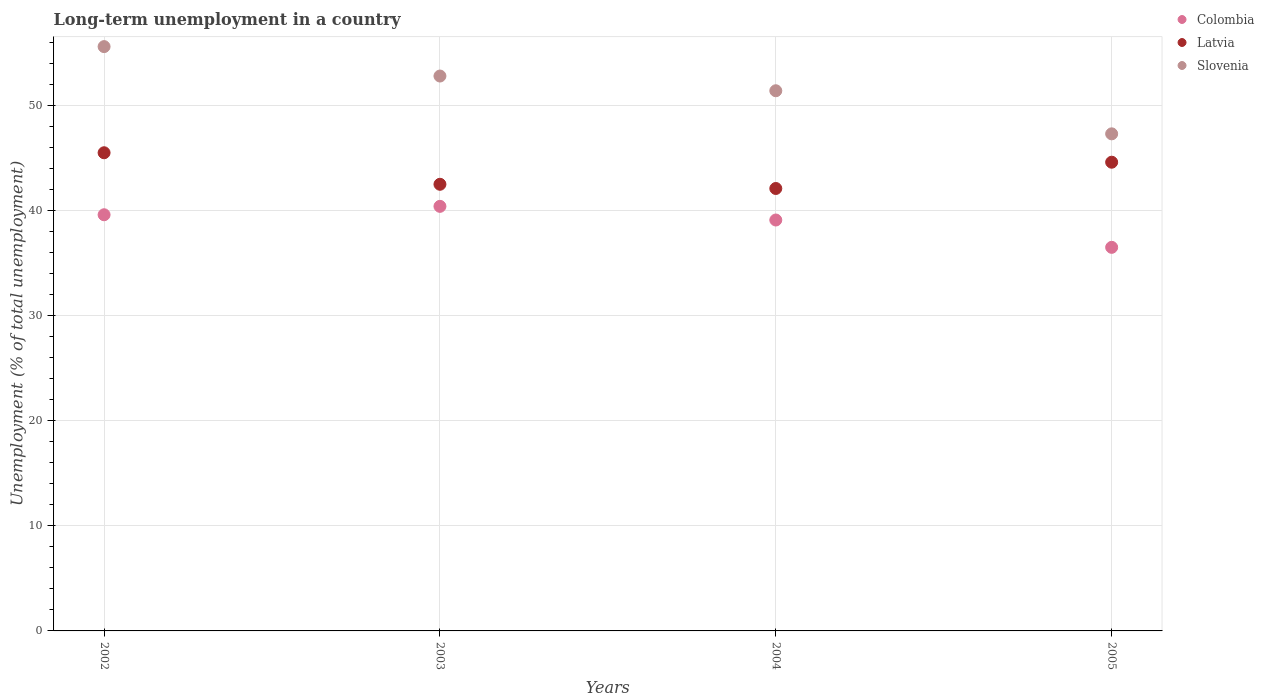What is the percentage of long-term unemployed population in Slovenia in 2005?
Give a very brief answer. 47.3. Across all years, what is the maximum percentage of long-term unemployed population in Latvia?
Your response must be concise. 45.5. Across all years, what is the minimum percentage of long-term unemployed population in Colombia?
Keep it short and to the point. 36.5. What is the total percentage of long-term unemployed population in Colombia in the graph?
Your response must be concise. 155.6. What is the difference between the percentage of long-term unemployed population in Colombia in 2004 and that in 2005?
Give a very brief answer. 2.6. What is the difference between the percentage of long-term unemployed population in Slovenia in 2004 and the percentage of long-term unemployed population in Colombia in 2002?
Your answer should be compact. 11.8. What is the average percentage of long-term unemployed population in Latvia per year?
Your answer should be compact. 43.67. In the year 2004, what is the difference between the percentage of long-term unemployed population in Colombia and percentage of long-term unemployed population in Slovenia?
Offer a terse response. -12.3. What is the ratio of the percentage of long-term unemployed population in Latvia in 2002 to that in 2005?
Offer a terse response. 1.02. Is the difference between the percentage of long-term unemployed population in Colombia in 2002 and 2004 greater than the difference between the percentage of long-term unemployed population in Slovenia in 2002 and 2004?
Keep it short and to the point. No. What is the difference between the highest and the second highest percentage of long-term unemployed population in Latvia?
Your answer should be very brief. 0.9. What is the difference between the highest and the lowest percentage of long-term unemployed population in Colombia?
Provide a succinct answer. 3.9. In how many years, is the percentage of long-term unemployed population in Slovenia greater than the average percentage of long-term unemployed population in Slovenia taken over all years?
Make the answer very short. 2. Is the sum of the percentage of long-term unemployed population in Slovenia in 2002 and 2003 greater than the maximum percentage of long-term unemployed population in Colombia across all years?
Give a very brief answer. Yes. Is the percentage of long-term unemployed population in Slovenia strictly greater than the percentage of long-term unemployed population in Latvia over the years?
Provide a short and direct response. Yes. Is the percentage of long-term unemployed population in Latvia strictly less than the percentage of long-term unemployed population in Colombia over the years?
Give a very brief answer. No. How many dotlines are there?
Give a very brief answer. 3. How many years are there in the graph?
Your answer should be compact. 4. How many legend labels are there?
Make the answer very short. 3. What is the title of the graph?
Your response must be concise. Long-term unemployment in a country. What is the label or title of the Y-axis?
Ensure brevity in your answer.  Unemployment (% of total unemployment). What is the Unemployment (% of total unemployment) of Colombia in 2002?
Your answer should be very brief. 39.6. What is the Unemployment (% of total unemployment) of Latvia in 2002?
Ensure brevity in your answer.  45.5. What is the Unemployment (% of total unemployment) in Slovenia in 2002?
Make the answer very short. 55.6. What is the Unemployment (% of total unemployment) of Colombia in 2003?
Your answer should be compact. 40.4. What is the Unemployment (% of total unemployment) of Latvia in 2003?
Provide a short and direct response. 42.5. What is the Unemployment (% of total unemployment) in Slovenia in 2003?
Provide a short and direct response. 52.8. What is the Unemployment (% of total unemployment) of Colombia in 2004?
Offer a very short reply. 39.1. What is the Unemployment (% of total unemployment) in Latvia in 2004?
Provide a short and direct response. 42.1. What is the Unemployment (% of total unemployment) in Slovenia in 2004?
Your answer should be very brief. 51.4. What is the Unemployment (% of total unemployment) in Colombia in 2005?
Provide a succinct answer. 36.5. What is the Unemployment (% of total unemployment) in Latvia in 2005?
Your response must be concise. 44.6. What is the Unemployment (% of total unemployment) in Slovenia in 2005?
Your answer should be very brief. 47.3. Across all years, what is the maximum Unemployment (% of total unemployment) of Colombia?
Your response must be concise. 40.4. Across all years, what is the maximum Unemployment (% of total unemployment) of Latvia?
Provide a succinct answer. 45.5. Across all years, what is the maximum Unemployment (% of total unemployment) in Slovenia?
Provide a succinct answer. 55.6. Across all years, what is the minimum Unemployment (% of total unemployment) of Colombia?
Your response must be concise. 36.5. Across all years, what is the minimum Unemployment (% of total unemployment) in Latvia?
Provide a succinct answer. 42.1. Across all years, what is the minimum Unemployment (% of total unemployment) in Slovenia?
Provide a succinct answer. 47.3. What is the total Unemployment (% of total unemployment) in Colombia in the graph?
Your answer should be very brief. 155.6. What is the total Unemployment (% of total unemployment) of Latvia in the graph?
Keep it short and to the point. 174.7. What is the total Unemployment (% of total unemployment) of Slovenia in the graph?
Your answer should be compact. 207.1. What is the difference between the Unemployment (% of total unemployment) in Colombia in 2002 and that in 2005?
Provide a succinct answer. 3.1. What is the difference between the Unemployment (% of total unemployment) in Slovenia in 2003 and that in 2004?
Your answer should be very brief. 1.4. What is the difference between the Unemployment (% of total unemployment) in Colombia in 2003 and that in 2005?
Your response must be concise. 3.9. What is the difference between the Unemployment (% of total unemployment) of Latvia in 2003 and that in 2005?
Your answer should be compact. -2.1. What is the difference between the Unemployment (% of total unemployment) in Slovenia in 2003 and that in 2005?
Your answer should be very brief. 5.5. What is the difference between the Unemployment (% of total unemployment) in Colombia in 2004 and that in 2005?
Keep it short and to the point. 2.6. What is the difference between the Unemployment (% of total unemployment) in Slovenia in 2004 and that in 2005?
Your response must be concise. 4.1. What is the difference between the Unemployment (% of total unemployment) of Colombia in 2002 and the Unemployment (% of total unemployment) of Latvia in 2003?
Keep it short and to the point. -2.9. What is the difference between the Unemployment (% of total unemployment) of Colombia in 2002 and the Unemployment (% of total unemployment) of Slovenia in 2003?
Your answer should be compact. -13.2. What is the difference between the Unemployment (% of total unemployment) of Colombia in 2002 and the Unemployment (% of total unemployment) of Slovenia in 2004?
Your answer should be compact. -11.8. What is the difference between the Unemployment (% of total unemployment) in Colombia in 2002 and the Unemployment (% of total unemployment) in Latvia in 2005?
Make the answer very short. -5. What is the difference between the Unemployment (% of total unemployment) of Colombia in 2002 and the Unemployment (% of total unemployment) of Slovenia in 2005?
Offer a very short reply. -7.7. What is the difference between the Unemployment (% of total unemployment) of Latvia in 2003 and the Unemployment (% of total unemployment) of Slovenia in 2004?
Provide a succinct answer. -8.9. What is the difference between the Unemployment (% of total unemployment) in Colombia in 2003 and the Unemployment (% of total unemployment) in Latvia in 2005?
Your answer should be very brief. -4.2. What is the difference between the Unemployment (% of total unemployment) in Colombia in 2003 and the Unemployment (% of total unemployment) in Slovenia in 2005?
Offer a very short reply. -6.9. What is the difference between the Unemployment (% of total unemployment) of Latvia in 2003 and the Unemployment (% of total unemployment) of Slovenia in 2005?
Offer a terse response. -4.8. What is the difference between the Unemployment (% of total unemployment) of Colombia in 2004 and the Unemployment (% of total unemployment) of Latvia in 2005?
Provide a short and direct response. -5.5. What is the difference between the Unemployment (% of total unemployment) of Colombia in 2004 and the Unemployment (% of total unemployment) of Slovenia in 2005?
Your response must be concise. -8.2. What is the difference between the Unemployment (% of total unemployment) in Latvia in 2004 and the Unemployment (% of total unemployment) in Slovenia in 2005?
Provide a succinct answer. -5.2. What is the average Unemployment (% of total unemployment) of Colombia per year?
Provide a succinct answer. 38.9. What is the average Unemployment (% of total unemployment) in Latvia per year?
Provide a short and direct response. 43.67. What is the average Unemployment (% of total unemployment) of Slovenia per year?
Make the answer very short. 51.77. In the year 2002, what is the difference between the Unemployment (% of total unemployment) in Latvia and Unemployment (% of total unemployment) in Slovenia?
Ensure brevity in your answer.  -10.1. In the year 2003, what is the difference between the Unemployment (% of total unemployment) of Colombia and Unemployment (% of total unemployment) of Latvia?
Provide a succinct answer. -2.1. In the year 2003, what is the difference between the Unemployment (% of total unemployment) in Colombia and Unemployment (% of total unemployment) in Slovenia?
Your answer should be very brief. -12.4. In the year 2004, what is the difference between the Unemployment (% of total unemployment) in Latvia and Unemployment (% of total unemployment) in Slovenia?
Offer a terse response. -9.3. In the year 2005, what is the difference between the Unemployment (% of total unemployment) in Colombia and Unemployment (% of total unemployment) in Latvia?
Offer a very short reply. -8.1. In the year 2005, what is the difference between the Unemployment (% of total unemployment) of Colombia and Unemployment (% of total unemployment) of Slovenia?
Provide a short and direct response. -10.8. In the year 2005, what is the difference between the Unemployment (% of total unemployment) in Latvia and Unemployment (% of total unemployment) in Slovenia?
Keep it short and to the point. -2.7. What is the ratio of the Unemployment (% of total unemployment) of Colombia in 2002 to that in 2003?
Your answer should be compact. 0.98. What is the ratio of the Unemployment (% of total unemployment) in Latvia in 2002 to that in 2003?
Your answer should be compact. 1.07. What is the ratio of the Unemployment (% of total unemployment) of Slovenia in 2002 to that in 2003?
Offer a very short reply. 1.05. What is the ratio of the Unemployment (% of total unemployment) in Colombia in 2002 to that in 2004?
Offer a terse response. 1.01. What is the ratio of the Unemployment (% of total unemployment) in Latvia in 2002 to that in 2004?
Keep it short and to the point. 1.08. What is the ratio of the Unemployment (% of total unemployment) of Slovenia in 2002 to that in 2004?
Provide a succinct answer. 1.08. What is the ratio of the Unemployment (% of total unemployment) in Colombia in 2002 to that in 2005?
Make the answer very short. 1.08. What is the ratio of the Unemployment (% of total unemployment) of Latvia in 2002 to that in 2005?
Offer a very short reply. 1.02. What is the ratio of the Unemployment (% of total unemployment) of Slovenia in 2002 to that in 2005?
Provide a short and direct response. 1.18. What is the ratio of the Unemployment (% of total unemployment) of Colombia in 2003 to that in 2004?
Offer a very short reply. 1.03. What is the ratio of the Unemployment (% of total unemployment) of Latvia in 2003 to that in 2004?
Offer a terse response. 1.01. What is the ratio of the Unemployment (% of total unemployment) in Slovenia in 2003 to that in 2004?
Offer a very short reply. 1.03. What is the ratio of the Unemployment (% of total unemployment) in Colombia in 2003 to that in 2005?
Keep it short and to the point. 1.11. What is the ratio of the Unemployment (% of total unemployment) in Latvia in 2003 to that in 2005?
Offer a terse response. 0.95. What is the ratio of the Unemployment (% of total unemployment) in Slovenia in 2003 to that in 2005?
Offer a terse response. 1.12. What is the ratio of the Unemployment (% of total unemployment) of Colombia in 2004 to that in 2005?
Your answer should be very brief. 1.07. What is the ratio of the Unemployment (% of total unemployment) of Latvia in 2004 to that in 2005?
Keep it short and to the point. 0.94. What is the ratio of the Unemployment (% of total unemployment) in Slovenia in 2004 to that in 2005?
Make the answer very short. 1.09. What is the difference between the highest and the second highest Unemployment (% of total unemployment) in Colombia?
Your response must be concise. 0.8. What is the difference between the highest and the second highest Unemployment (% of total unemployment) in Slovenia?
Offer a terse response. 2.8. 